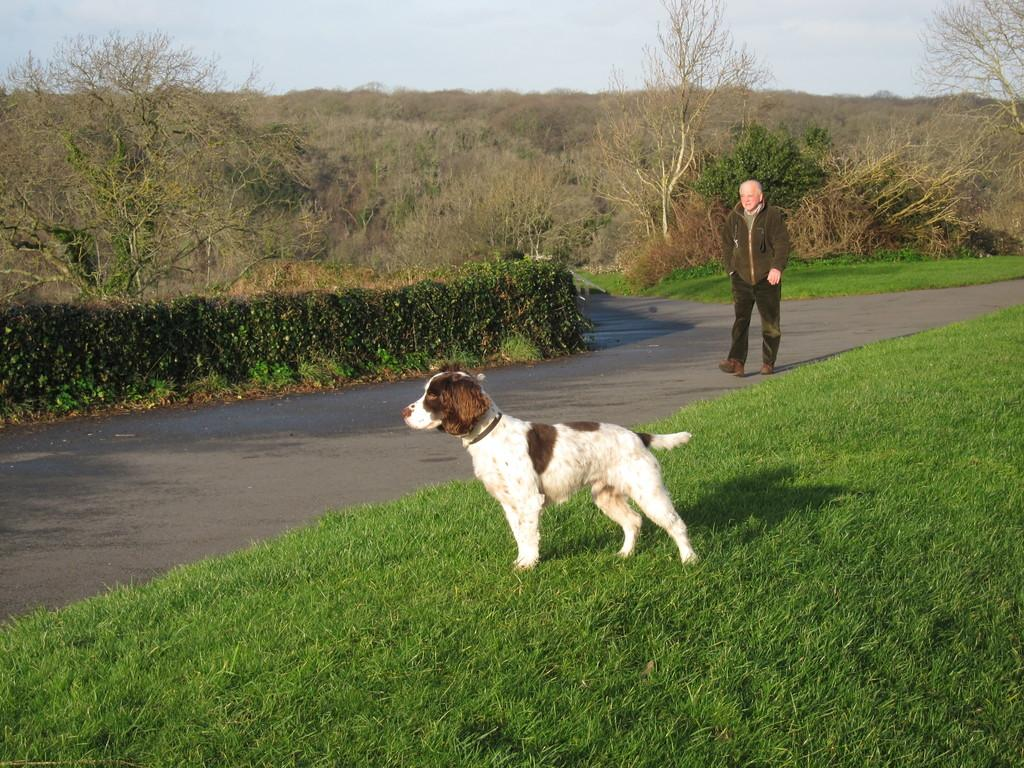What animal is on the grass in the image? There is a dog on the grass in the image. What is the man in the image doing? The man in the image is walking on the road. What can be seen in the background of the image? There are trees, plants, and the sky visible in the background of the image. What type of skate is the dog riding in the image? There is no skate present in the image; the dog is on the grass. How many clouds can be seen in the image? The provided facts do not specify the number of clouds in the image, but the sky is visible in the background. 